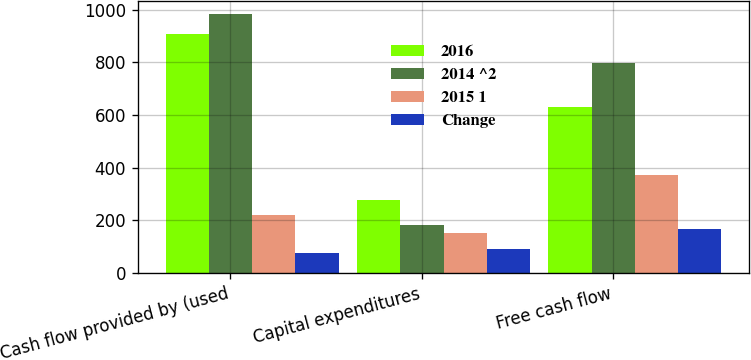<chart> <loc_0><loc_0><loc_500><loc_500><stacked_bar_chart><ecel><fcel>Cash flow provided by (used<fcel>Capital expenditures<fcel>Free cash flow<nl><fcel>2016<fcel>906.9<fcel>275.7<fcel>631.2<nl><fcel>2014 ^2<fcel>982.1<fcel>184<fcel>798.1<nl><fcel>2015 1<fcel>218.8<fcel>153.9<fcel>372.7<nl><fcel>Change<fcel>75.2<fcel>91.7<fcel>166.9<nl></chart> 